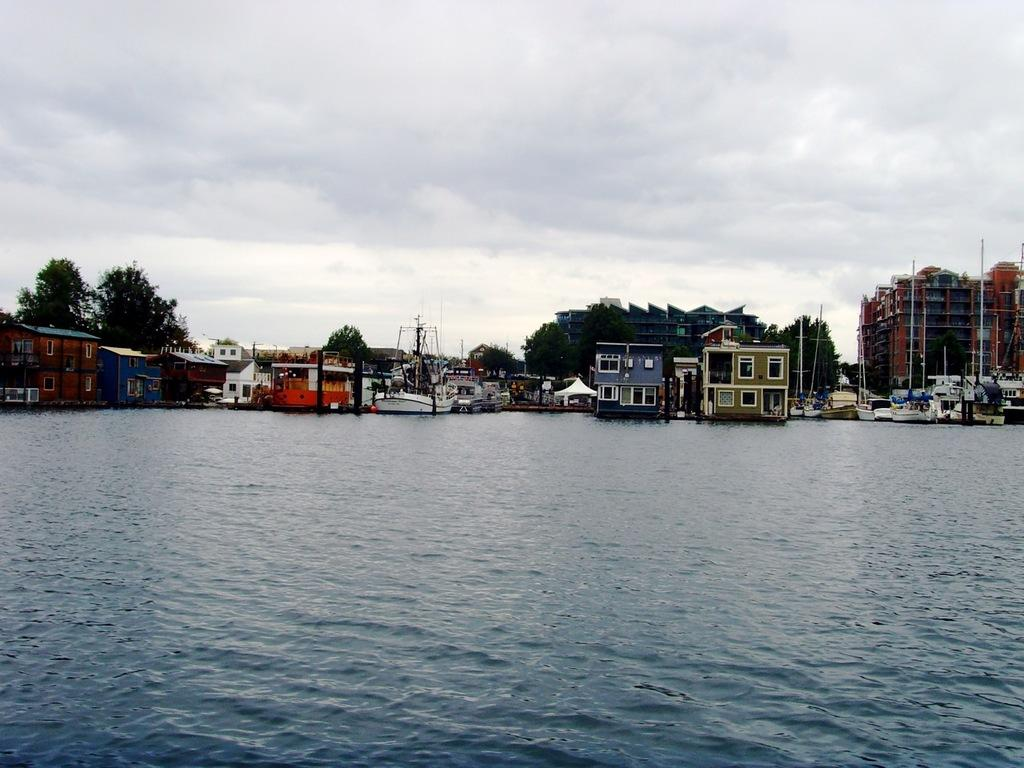What type of structures can be seen in the image? There are buildings in the image. What is on the water in the image? There are boats on the water in the image. What objects are present in the image that are taller than the surrounding environment? There are poles in the image. What type of vegetation is visible in the image? There are trees in the image. What can be seen in the background of the image? The sky is visible in the background of the image. How many sheep are grazing near the buildings in the image? There are no sheep present in the image; it features buildings, boats, poles, trees, and the sky. What type of knee is visible in the image? There is no knee present in the image. 